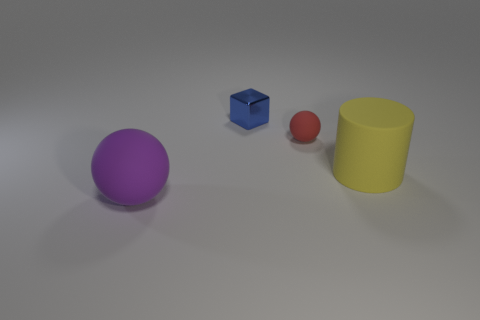How many tiny red objects have the same shape as the large purple rubber object?
Offer a very short reply. 1. What is the size of the yellow cylinder that is made of the same material as the large purple ball?
Your answer should be compact. Large. Is the size of the purple ball the same as the red rubber sphere?
Make the answer very short. No. Is there a yellow rubber cylinder?
Provide a short and direct response. Yes. What size is the rubber ball that is behind the big rubber thing behind the matte sphere that is in front of the yellow cylinder?
Your response must be concise. Small. What number of other objects are the same material as the big purple object?
Provide a succinct answer. 2. What number of yellow rubber things have the same size as the purple rubber ball?
Keep it short and to the point. 1. There is a blue cube that is behind the large matte object that is on the left side of the big object on the right side of the blue metallic block; what is its material?
Provide a succinct answer. Metal. What number of objects are big yellow matte things or tiny blue metal cubes?
Offer a terse response. 2. Are there any other things that have the same material as the tiny block?
Your response must be concise. No. 